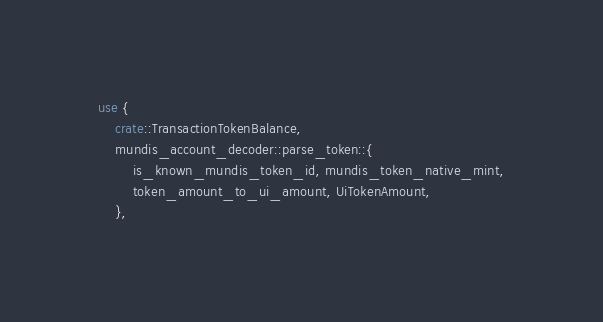Convert code to text. <code><loc_0><loc_0><loc_500><loc_500><_Rust_>use {
    crate::TransactionTokenBalance,
    mundis_account_decoder::parse_token::{
        is_known_mundis_token_id, mundis_token_native_mint,
        token_amount_to_ui_amount, UiTokenAmount,
    },</code> 